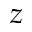<formula> <loc_0><loc_0><loc_500><loc_500>z</formula> 